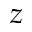<formula> <loc_0><loc_0><loc_500><loc_500>z</formula> 